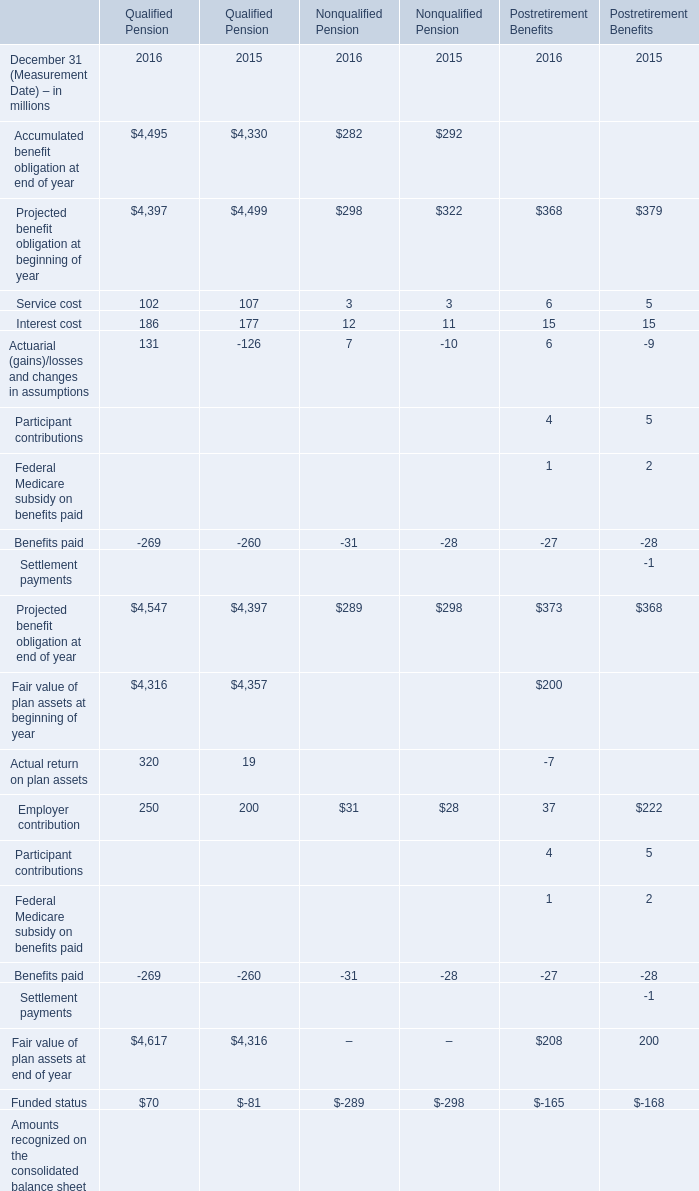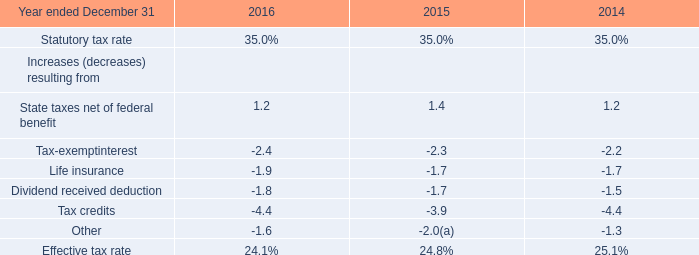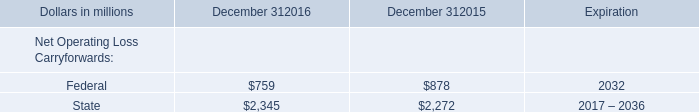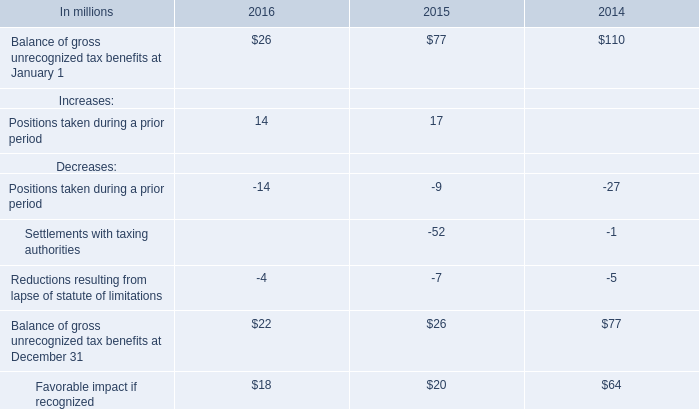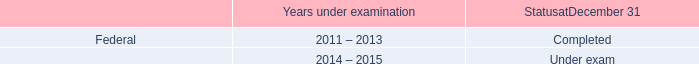What's the total amount of the State taxes net of federal benefit in the years where Federal for Net Operating Loss Carryforwards is greater than 700? 
Computations: (1.2 + 1.4)
Answer: 2.6. 